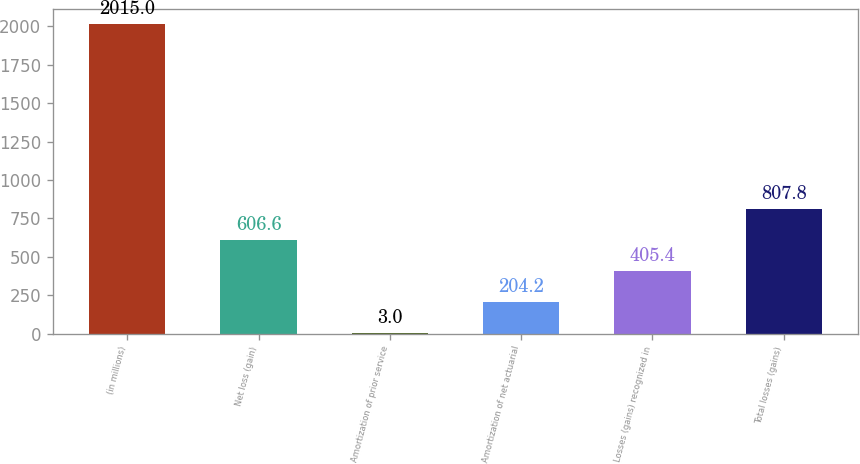Convert chart to OTSL. <chart><loc_0><loc_0><loc_500><loc_500><bar_chart><fcel>(in millions)<fcel>Net loss (gain)<fcel>Amortization of prior service<fcel>Amortization of net actuarial<fcel>Losses (gains) recognized in<fcel>Total losses (gains)<nl><fcel>2015<fcel>606.6<fcel>3<fcel>204.2<fcel>405.4<fcel>807.8<nl></chart> 